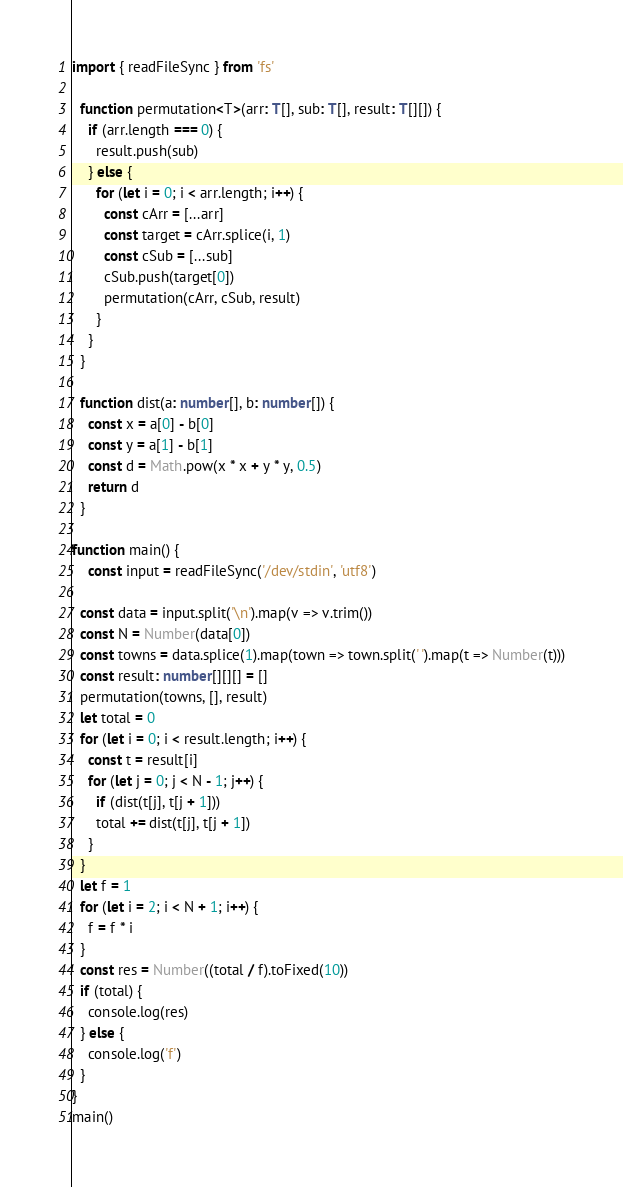<code> <loc_0><loc_0><loc_500><loc_500><_TypeScript_>import { readFileSync } from 'fs'

  function permutation<T>(arr: T[], sub: T[], result: T[][]) {
    if (arr.length === 0) {
      result.push(sub)
    } else {
      for (let i = 0; i < arr.length; i++) {
        const cArr = [...arr]
        const target = cArr.splice(i, 1)
        const cSub = [...sub]
        cSub.push(target[0])
        permutation(cArr, cSub, result)        
      }
    }
  }

  function dist(a: number[], b: number[]) {
    const x = a[0] - b[0]
    const y = a[1] - b[1]
    const d = Math.pow(x * x + y * y, 0.5)
    return d
  }

function main() {
	const input = readFileSync('/dev/stdin', 'utf8')

  const data = input.split('\n').map(v => v.trim())
  const N = Number(data[0])
  const towns = data.splice(1).map(town => town.split(' ').map(t => Number(t)))
  const result: number[][][] = []
  permutation(towns, [], result)
  let total = 0
  for (let i = 0; i < result.length; i++) {
    const t = result[i]
    for (let j = 0; j < N - 1; j++) {
      if (dist(t[j], t[j + 1]))
      total += dist(t[j], t[j + 1])      
    }
  }
  let f = 1
  for (let i = 2; i < N + 1; i++) {
    f = f * i
  }
  const res = Number((total / f).toFixed(10))
  if (total) {
    console.log(res)
  } else {
    console.log('f')
  }
}
main()
</code> 